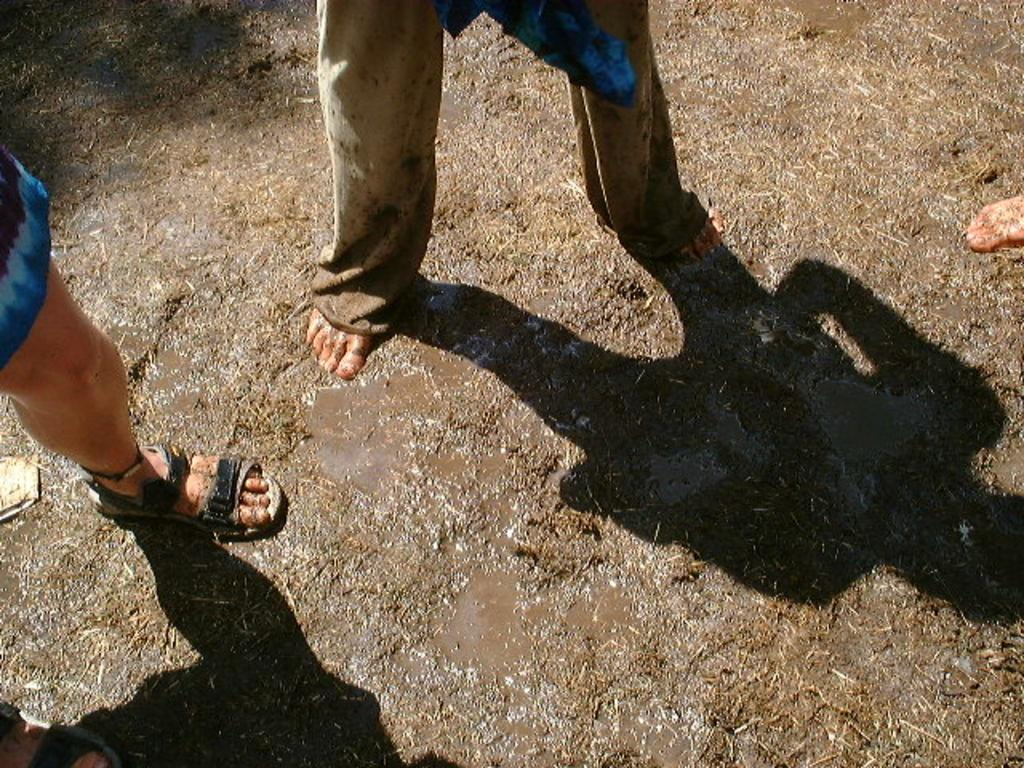How many people are in the image? There are three persons in the image. What is the surface on which the persons are standing? The persons are standing on a muddy surface. What type of box can be seen in the image? There is no box present in the image. What kind of jelly is being served to the persons in the image? There is no jelly present in the image. 